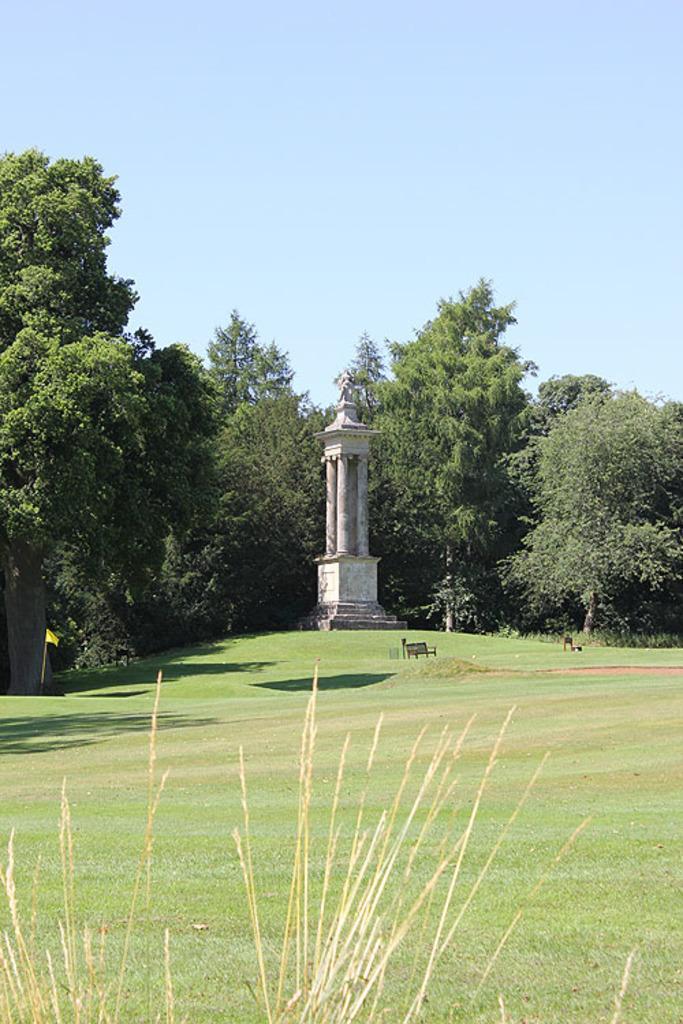Please provide a concise description of this image. In this image I see the grass and I see a monument over here and I see number of trees. In the background I see the sky. 